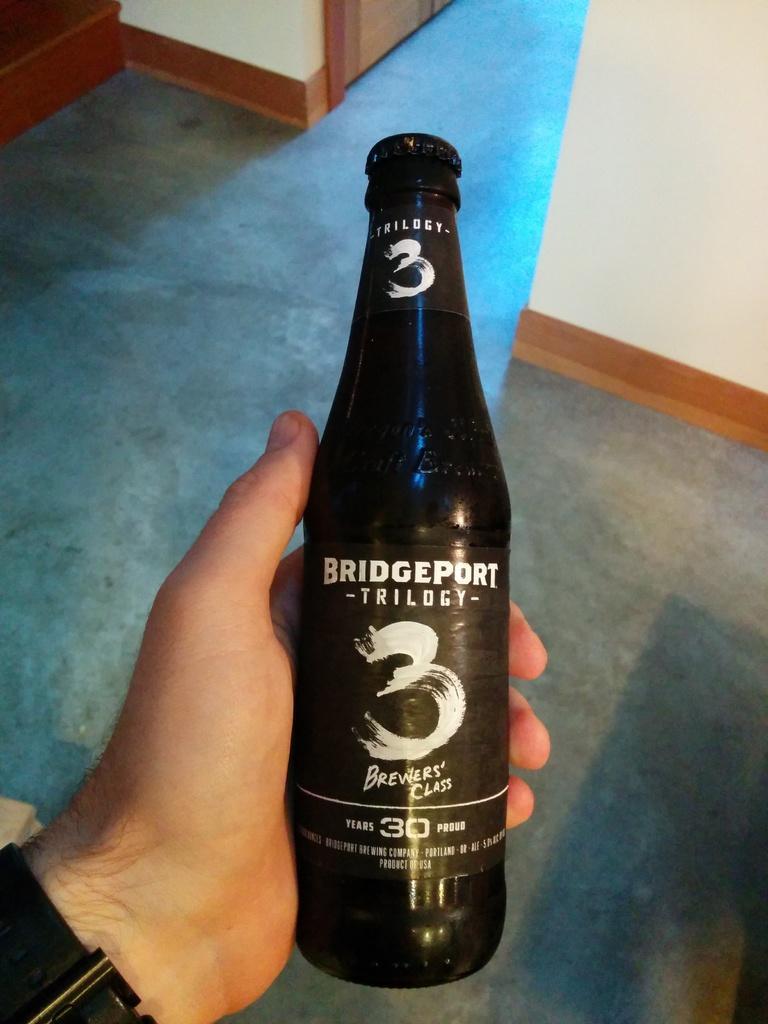Describe this image in one or two sentences. In this image we can see some person holding the black color bottle. In the background we can see the floor and also the wall. 